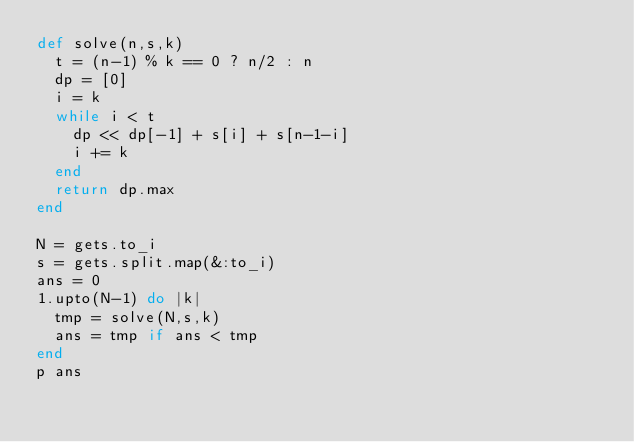<code> <loc_0><loc_0><loc_500><loc_500><_Ruby_>def solve(n,s,k)
  t = (n-1) % k == 0 ? n/2 : n
  dp = [0]
  i = k
  while i < t
    dp << dp[-1] + s[i] + s[n-1-i]
    i += k
  end
  return dp.max
end

N = gets.to_i
s = gets.split.map(&:to_i)
ans = 0
1.upto(N-1) do |k|
  tmp = solve(N,s,k)
  ans = tmp if ans < tmp
end
p ans</code> 